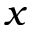Convert formula to latex. <formula><loc_0><loc_0><loc_500><loc_500>x</formula> 